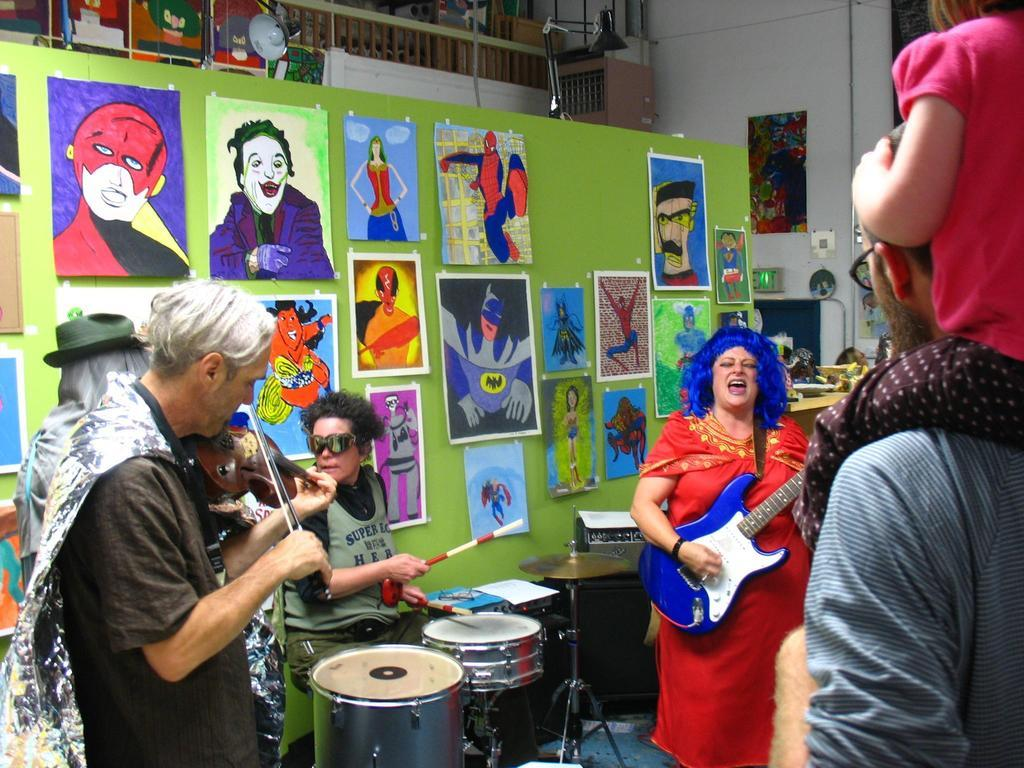What are the people in the image doing? The people in the image are standing and playing musical instruments. Can you describe the woman holding a guitar? Yes, a woman is holding a guitar in the image. What is the other woman doing in the image? The other woman is seated and playing drums. What can be seen on the wall in the image? There are posts on the wall in the image. How does the pollution affect the musical performance in the image? There is no mention of pollution in the image, so it cannot affect the musical performance. 